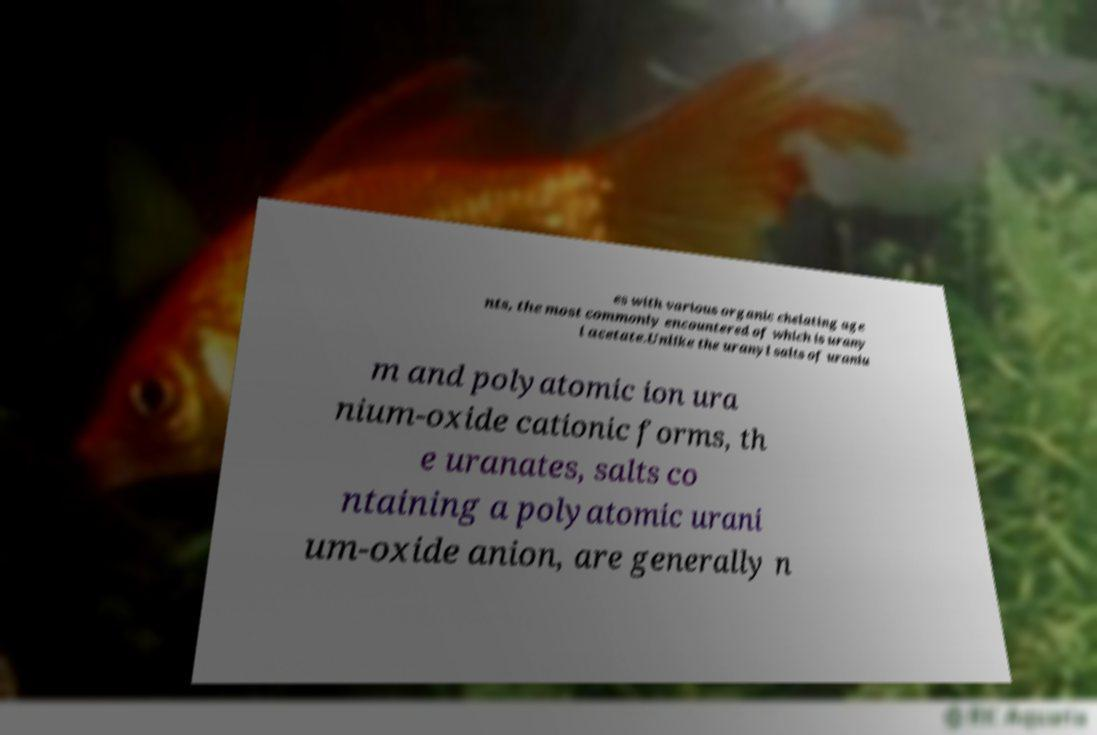Could you assist in decoding the text presented in this image and type it out clearly? es with various organic chelating age nts, the most commonly encountered of which is urany l acetate.Unlike the uranyl salts of uraniu m and polyatomic ion ura nium-oxide cationic forms, th e uranates, salts co ntaining a polyatomic urani um-oxide anion, are generally n 